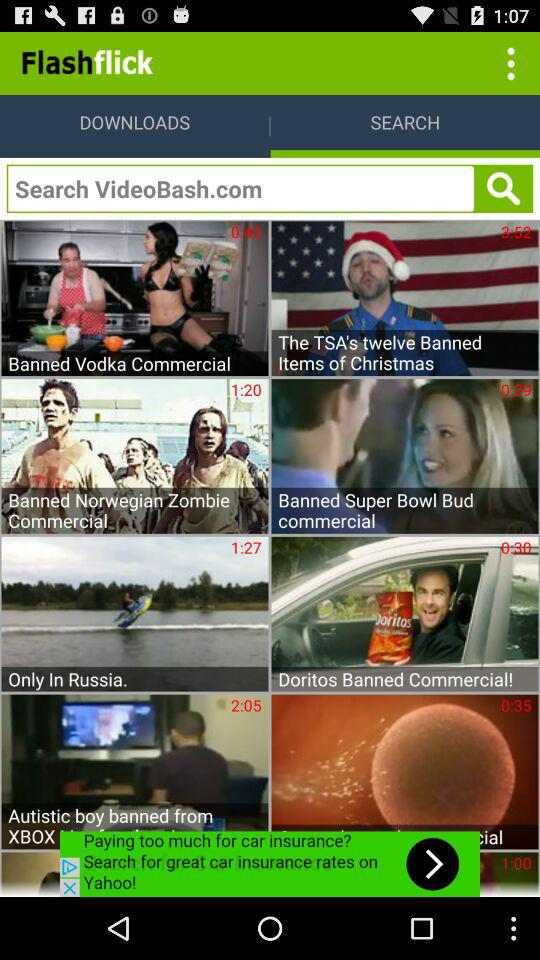What is the duration of the video titled "Banned Vodka Commercial"? The duration of the video titled "Banned Vodka Commercial" is 40 seconds. 